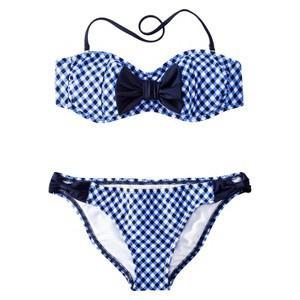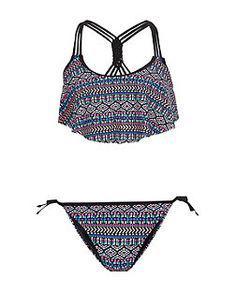The first image is the image on the left, the second image is the image on the right. Analyze the images presented: Is the assertion "One of the swimsuits has a floral pattern" valid? Answer yes or no. No. 